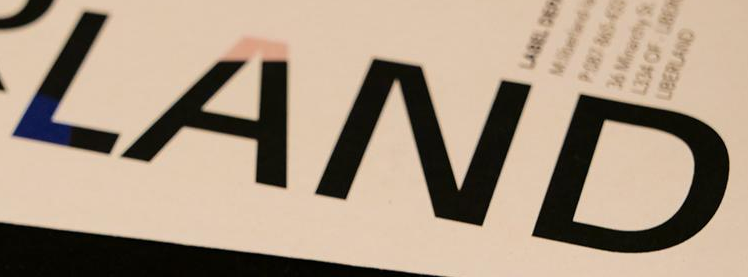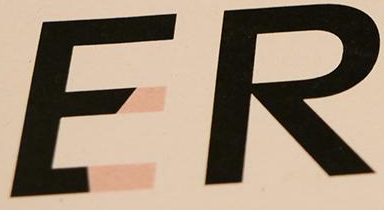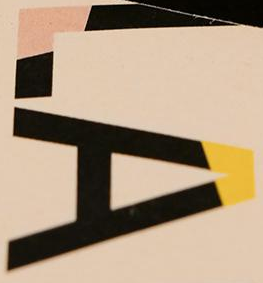What words are shown in these images in order, separated by a semicolon? LAND; ER; LA 